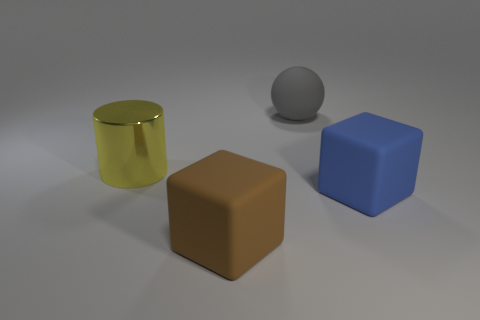There is a gray object; is its shape the same as the object that is on the left side of the big brown thing?
Offer a very short reply. No. There is a big thing left of the matte thing that is to the left of the object behind the big shiny thing; what is it made of?
Keep it short and to the point. Metal. What number of tiny objects are brown cubes or blue rubber blocks?
Provide a short and direct response. 0. How many other objects are there of the same size as the yellow cylinder?
Provide a short and direct response. 3. Do the big rubber thing that is to the left of the big gray rubber sphere and the big blue thing have the same shape?
Offer a very short reply. Yes. What color is the other thing that is the same shape as the big blue object?
Your answer should be very brief. Brown. Are there any other things that have the same shape as the large gray matte object?
Your response must be concise. No. Are there the same number of large brown matte cubes that are on the right side of the matte ball and small shiny cylinders?
Your answer should be compact. Yes. What number of large things are both behind the big metallic thing and on the right side of the large gray rubber object?
Offer a terse response. 0. What number of brown cubes have the same material as the cylinder?
Offer a very short reply. 0. 